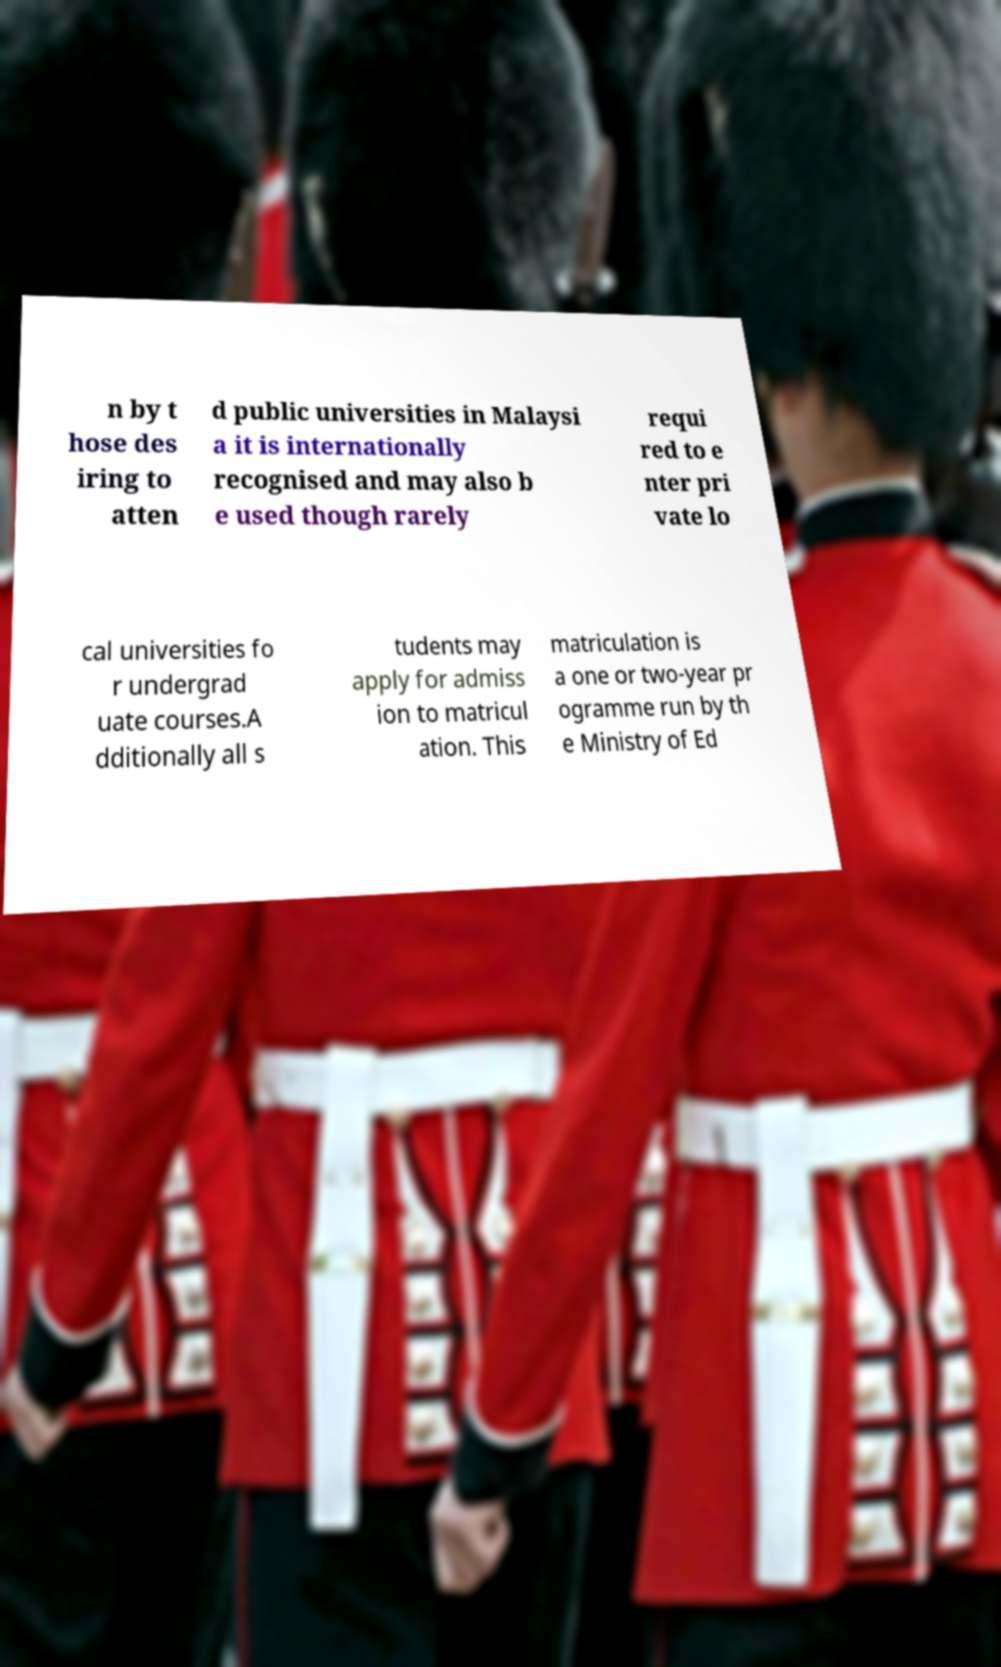Could you assist in decoding the text presented in this image and type it out clearly? n by t hose des iring to atten d public universities in Malaysi a it is internationally recognised and may also b e used though rarely requi red to e nter pri vate lo cal universities fo r undergrad uate courses.A dditionally all s tudents may apply for admiss ion to matricul ation. This matriculation is a one or two-year pr ogramme run by th e Ministry of Ed 